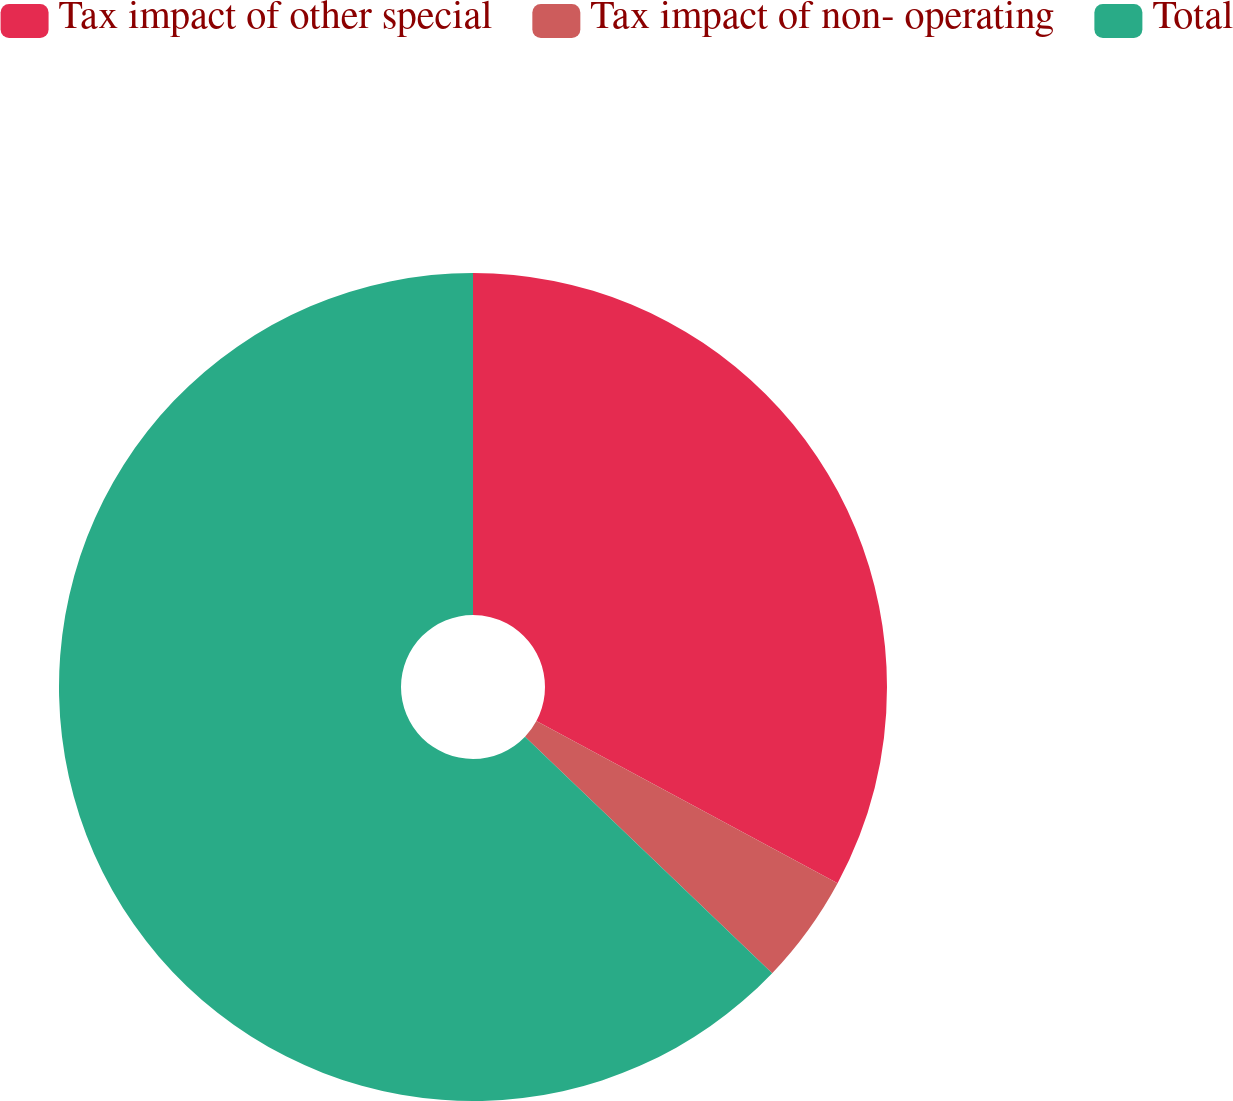<chart> <loc_0><loc_0><loc_500><loc_500><pie_chart><fcel>Tax impact of other special<fcel>Tax impact of non- operating<fcel>Total<nl><fcel>32.86%<fcel>4.29%<fcel>62.86%<nl></chart> 